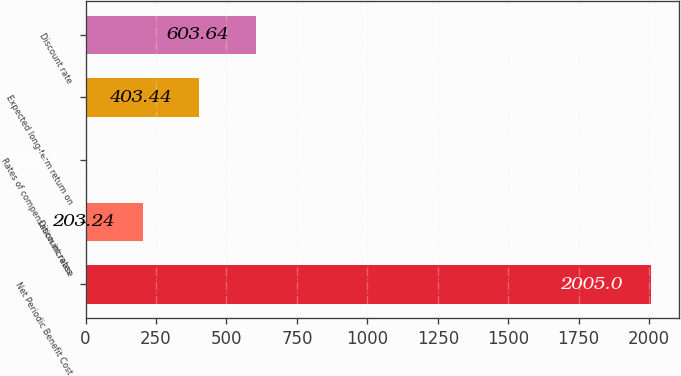Convert chart. <chart><loc_0><loc_0><loc_500><loc_500><bar_chart><fcel>Net Periodic Benefit Cost<fcel>Discount rates<fcel>Rates of compensation increase<fcel>Expected long-term return on<fcel>Discount rate<nl><fcel>2005<fcel>203.24<fcel>3.04<fcel>403.44<fcel>603.64<nl></chart> 